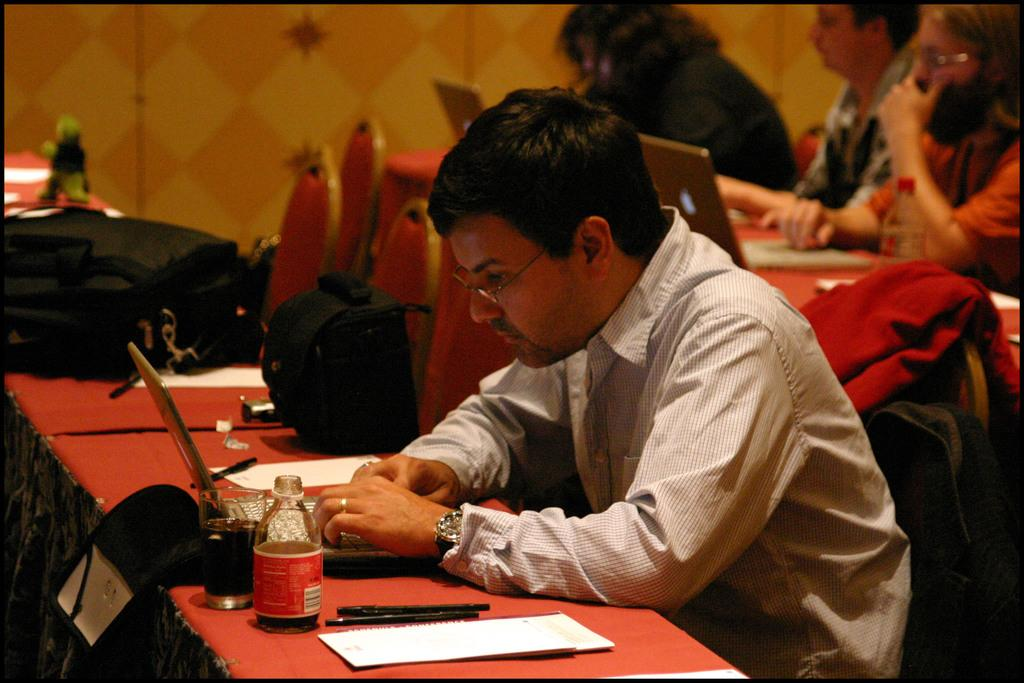What are the persons in the image doing? The persons in the image are sitting on chairs. What is on the table in the image? There is a laptop, a bottle, a glass, and a bag on the table. What is the primary object on the table? The primary object on the table is a laptop. What is visible on the wall in the image? The facts provided do not mention anything about the wall, so we cannot answer this question definitively. What type of railway is visible in the image? There is no railway present in the image. How many deaths have occurred in the image? There is no information about any deaths in the image. 